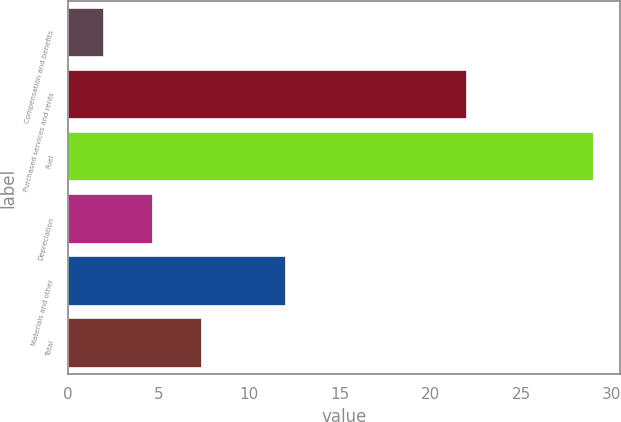Convert chart to OTSL. <chart><loc_0><loc_0><loc_500><loc_500><bar_chart><fcel>Compensation and benefits<fcel>Purchased services and rents<fcel>Fuel<fcel>Depreciation<fcel>Materials and other<fcel>Total<nl><fcel>2<fcel>22<fcel>29<fcel>4.7<fcel>12<fcel>7.4<nl></chart> 